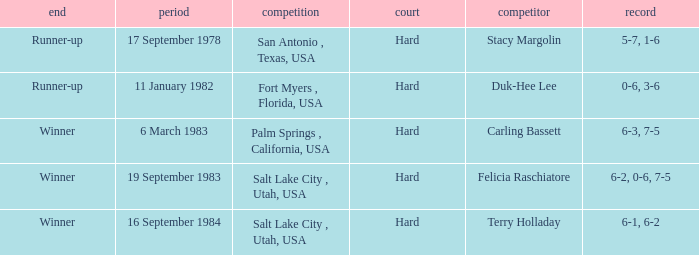What was the score of the match against duk-hee lee? 0-6, 3-6. I'm looking to parse the entire table for insights. Could you assist me with that? {'header': ['end', 'period', 'competition', 'court', 'competitor', 'record'], 'rows': [['Runner-up', '17 September 1978', 'San Antonio , Texas, USA', 'Hard', 'Stacy Margolin', '5-7, 1-6'], ['Runner-up', '11 January 1982', 'Fort Myers , Florida, USA', 'Hard', 'Duk-Hee Lee', '0-6, 3-6'], ['Winner', '6 March 1983', 'Palm Springs , California, USA', 'Hard', 'Carling Bassett', '6-3, 7-5'], ['Winner', '19 September 1983', 'Salt Lake City , Utah, USA', 'Hard', 'Felicia Raschiatore', '6-2, 0-6, 7-5'], ['Winner', '16 September 1984', 'Salt Lake City , Utah, USA', 'Hard', 'Terry Holladay', '6-1, 6-2']]} 